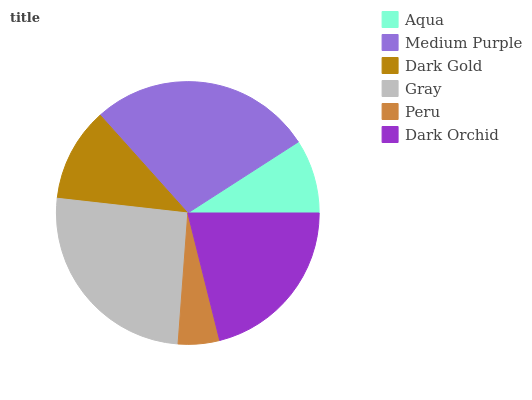Is Peru the minimum?
Answer yes or no. Yes. Is Medium Purple the maximum?
Answer yes or no. Yes. Is Dark Gold the minimum?
Answer yes or no. No. Is Dark Gold the maximum?
Answer yes or no. No. Is Medium Purple greater than Dark Gold?
Answer yes or no. Yes. Is Dark Gold less than Medium Purple?
Answer yes or no. Yes. Is Dark Gold greater than Medium Purple?
Answer yes or no. No. Is Medium Purple less than Dark Gold?
Answer yes or no. No. Is Dark Orchid the high median?
Answer yes or no. Yes. Is Dark Gold the low median?
Answer yes or no. Yes. Is Dark Gold the high median?
Answer yes or no. No. Is Peru the low median?
Answer yes or no. No. 